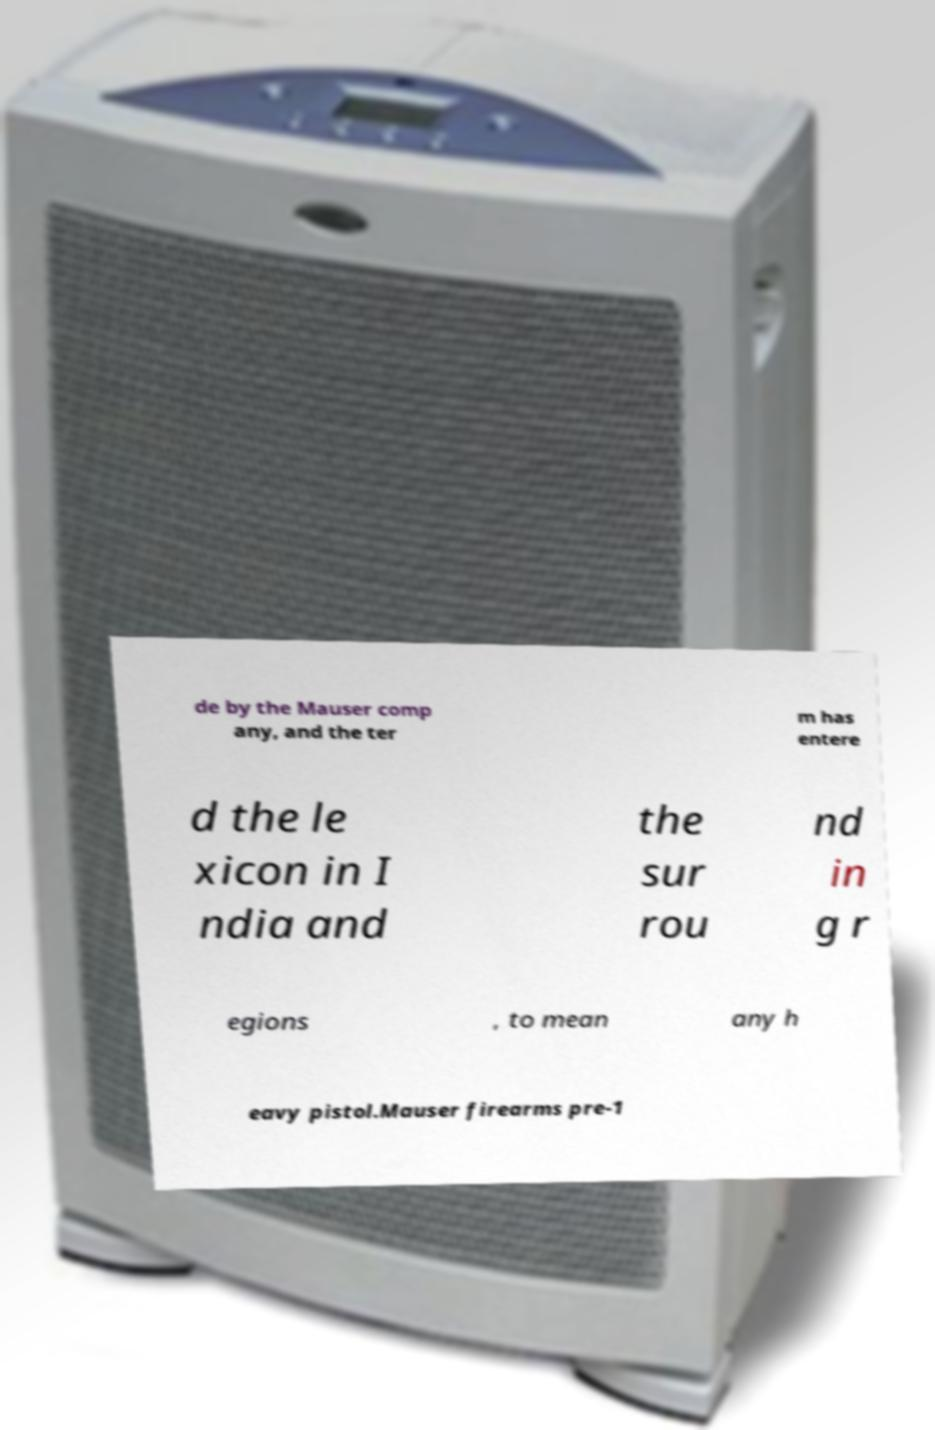What messages or text are displayed in this image? I need them in a readable, typed format. de by the Mauser comp any, and the ter m has entere d the le xicon in I ndia and the sur rou nd in g r egions , to mean any h eavy pistol.Mauser firearms pre-1 